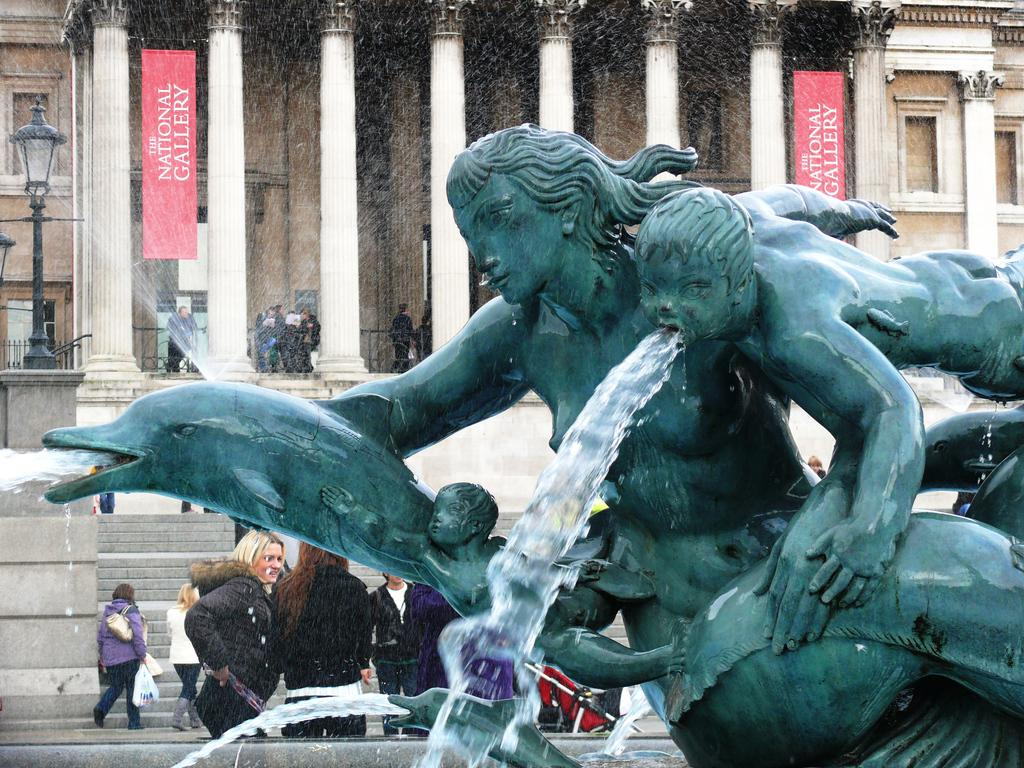What is the main subject of the image? There is a statue in the image. What is the color of the statue? The statue is green in color. What is happening with the statue in the image? Water is coming from the statue. What can be seen in the background of the image? There are pillars, people, boards, and buildings in the background of the image. Where is the wilderness area in the image? There is no wilderness area present in the image. What type of spot is visible on the statue in the image? There are no spots visible on the statue in the image. 